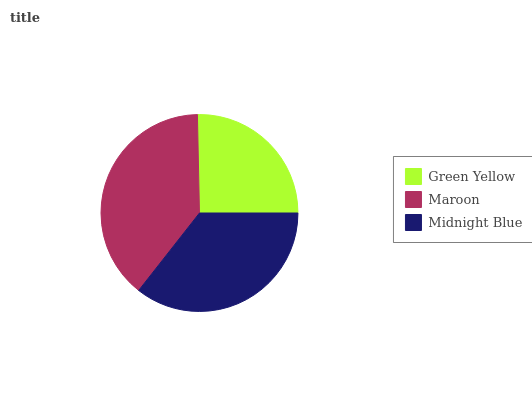Is Green Yellow the minimum?
Answer yes or no. Yes. Is Maroon the maximum?
Answer yes or no. Yes. Is Midnight Blue the minimum?
Answer yes or no. No. Is Midnight Blue the maximum?
Answer yes or no. No. Is Maroon greater than Midnight Blue?
Answer yes or no. Yes. Is Midnight Blue less than Maroon?
Answer yes or no. Yes. Is Midnight Blue greater than Maroon?
Answer yes or no. No. Is Maroon less than Midnight Blue?
Answer yes or no. No. Is Midnight Blue the high median?
Answer yes or no. Yes. Is Midnight Blue the low median?
Answer yes or no. Yes. Is Maroon the high median?
Answer yes or no. No. Is Green Yellow the low median?
Answer yes or no. No. 